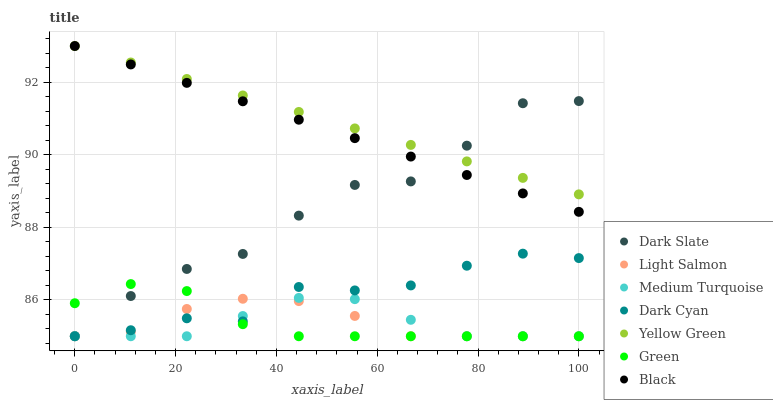Does Medium Turquoise have the minimum area under the curve?
Answer yes or no. Yes. Does Yellow Green have the maximum area under the curve?
Answer yes or no. Yes. Does Dark Slate have the minimum area under the curve?
Answer yes or no. No. Does Dark Slate have the maximum area under the curve?
Answer yes or no. No. Is Black the smoothest?
Answer yes or no. Yes. Is Dark Slate the roughest?
Answer yes or no. Yes. Is Yellow Green the smoothest?
Answer yes or no. No. Is Yellow Green the roughest?
Answer yes or no. No. Does Light Salmon have the lowest value?
Answer yes or no. Yes. Does Dark Slate have the lowest value?
Answer yes or no. No. Does Black have the highest value?
Answer yes or no. Yes. Does Dark Slate have the highest value?
Answer yes or no. No. Is Dark Cyan less than Dark Slate?
Answer yes or no. Yes. Is Black greater than Dark Cyan?
Answer yes or no. Yes. Does Medium Turquoise intersect Light Salmon?
Answer yes or no. Yes. Is Medium Turquoise less than Light Salmon?
Answer yes or no. No. Is Medium Turquoise greater than Light Salmon?
Answer yes or no. No. Does Dark Cyan intersect Dark Slate?
Answer yes or no. No. 